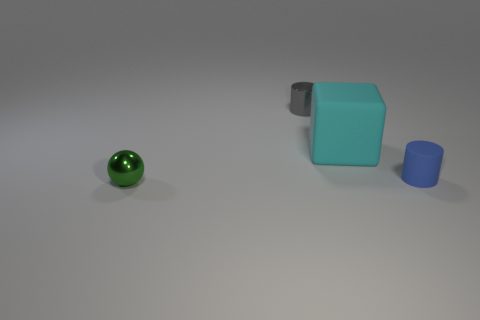There is a blue thing that is the same size as the shiny sphere; what is it made of?
Your response must be concise. Rubber. How many other things are there of the same material as the small gray cylinder?
Your answer should be compact. 1. There is a small thing behind the object to the right of the rubber cube; is there a sphere that is in front of it?
Your answer should be very brief. Yes. Is the small green ball made of the same material as the blue cylinder?
Make the answer very short. No. Is there any other thing that has the same shape as the cyan thing?
Provide a short and direct response. No. There is a small thing that is left of the metallic thing behind the small sphere; what is its material?
Offer a terse response. Metal. There is a rubber object behind the blue rubber object; how big is it?
Offer a very short reply. Large. What is the color of the tiny thing that is both in front of the tiny gray metal object and to the left of the tiny matte cylinder?
Keep it short and to the point. Green. Does the shiny thing in front of the blue cylinder have the same size as the cyan thing?
Offer a terse response. No. Are there any metallic objects that are to the right of the tiny metal object that is in front of the small gray cylinder?
Your response must be concise. Yes. 